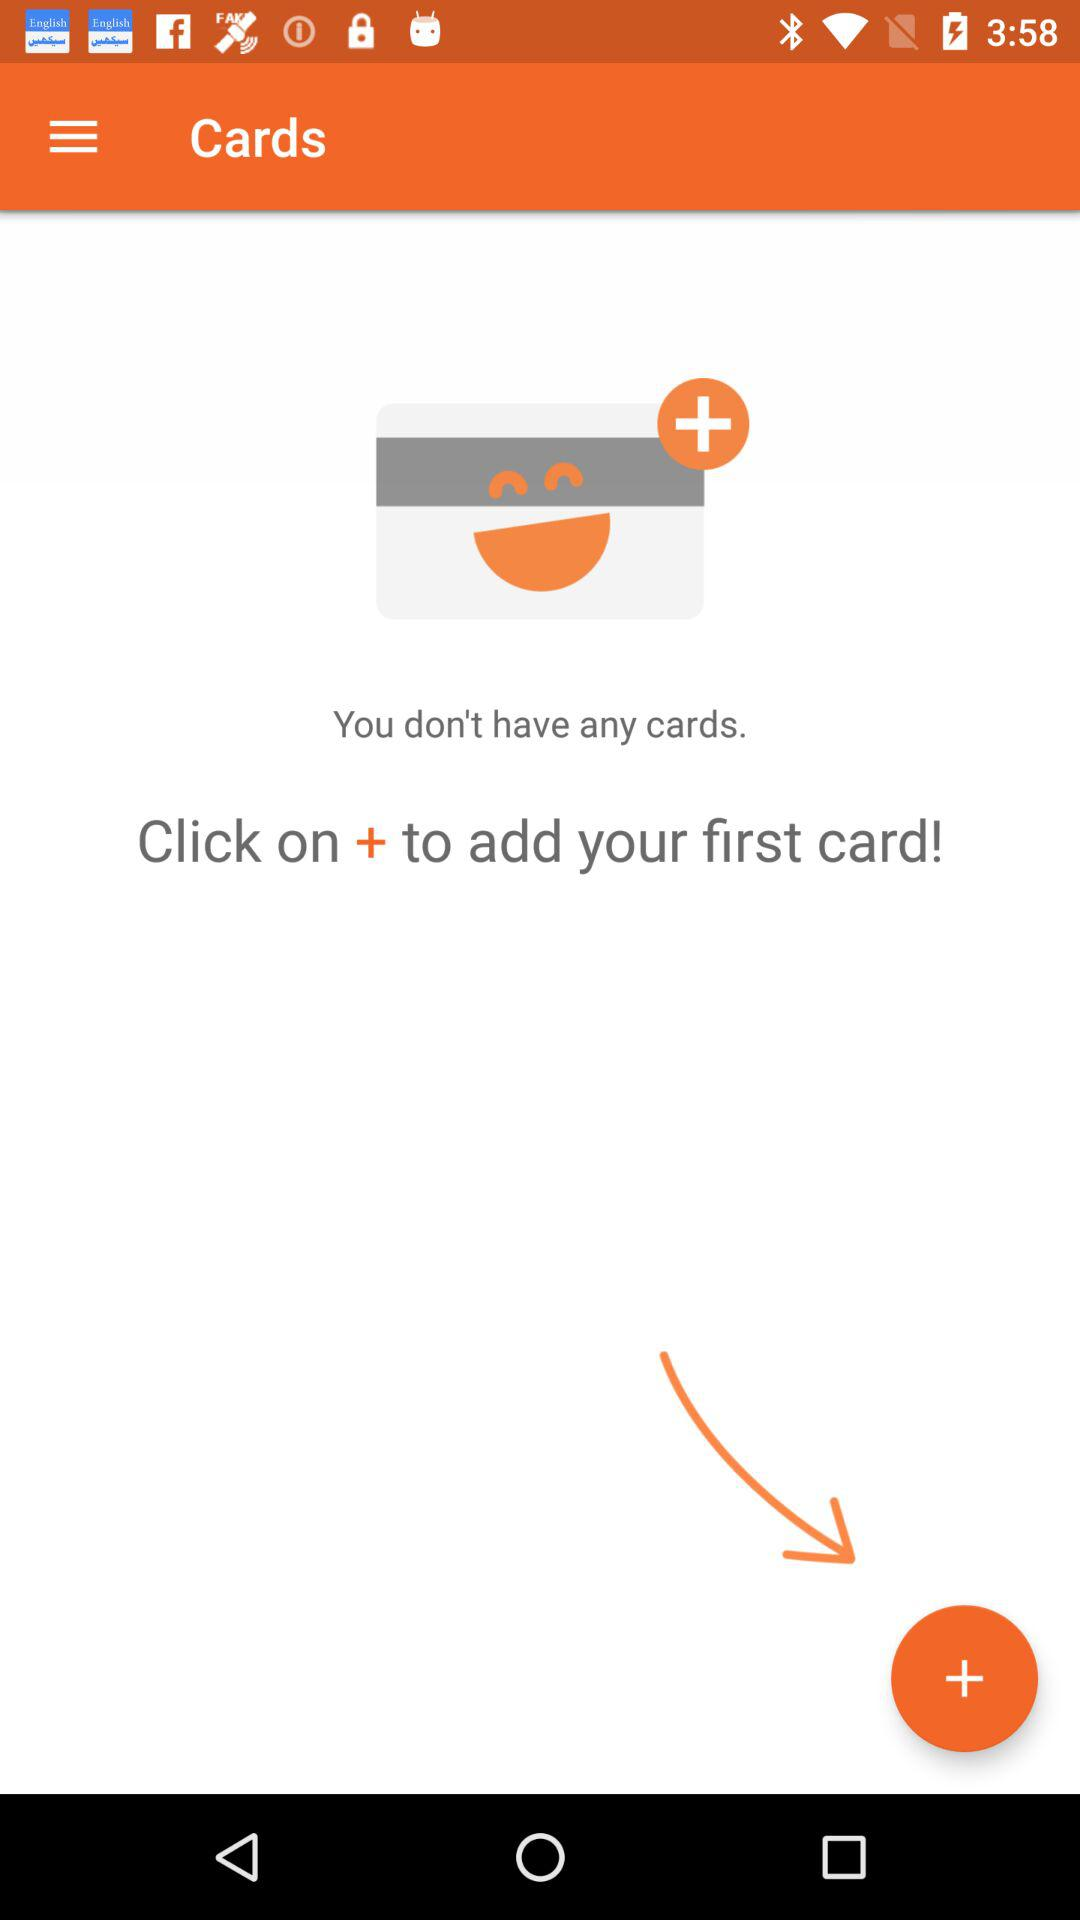How many cards do I have?
Answer the question using a single word or phrase. 0 